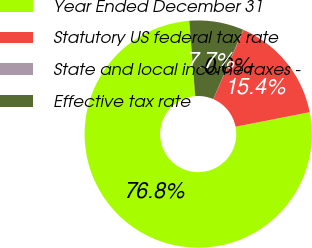Convert chart to OTSL. <chart><loc_0><loc_0><loc_500><loc_500><pie_chart><fcel>Year Ended December 31<fcel>Statutory US federal tax rate<fcel>State and local income taxes -<fcel>Effective tax rate<nl><fcel>76.84%<fcel>15.4%<fcel>0.04%<fcel>7.72%<nl></chart> 